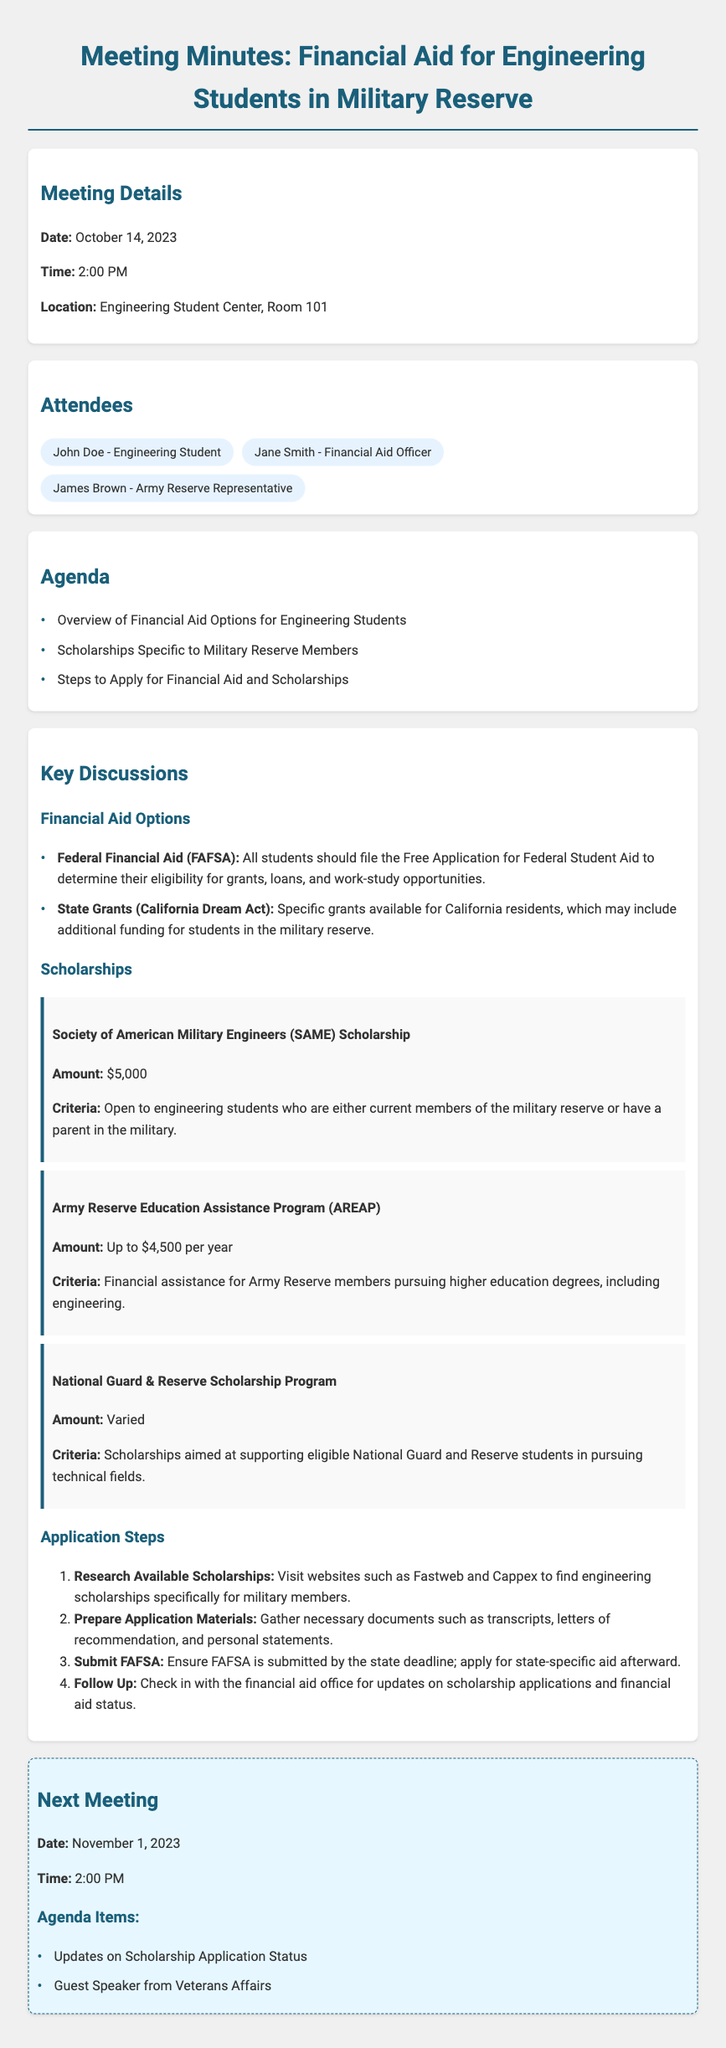what is the date of the meeting? The date of the meeting is explicitly stated in the document as October 14, 2023.
Answer: October 14, 2023 who is the Financial Aid Officer present at the meeting? The document lists Jane Smith as the Financial Aid Officer who attended the meeting.
Answer: Jane Smith how much is the Society of American Military Engineers (SAME) Scholarship? The document specifies the amount of the Same Scholarship as $5,000.
Answer: $5,000 what are the steps to apply for financial aid and scholarships? The document outlines several key steps, the first of which is to research available scholarships, followed by other specified steps.
Answer: Research Available Scholarships how much financial assistance is provided by the Army Reserve Education Assistance Program (AREAP)? The document states that the Army Reserve Education Assistance Program provides up to $4,500 per year.
Answer: Up to $4,500 per year what is the location of the meeting? The meeting’s location is mentioned as the Engineering Student Center, Room 101.
Answer: Engineering Student Center, Room 101 who are the attendees of the meeting? The attendees are listed in the document, which includes John Doe, Jane Smith, and James Brown.
Answer: John Doe, Jane Smith, James Brown when is the next meeting scheduled? The next meeting date is specified in the document as November 1, 2023.
Answer: November 1, 2023 what is one of the agenda items for the next meeting? The document includes updates on scholarship application status as one of the agenda items for the next meeting.
Answer: Updates on Scholarship Application Status 